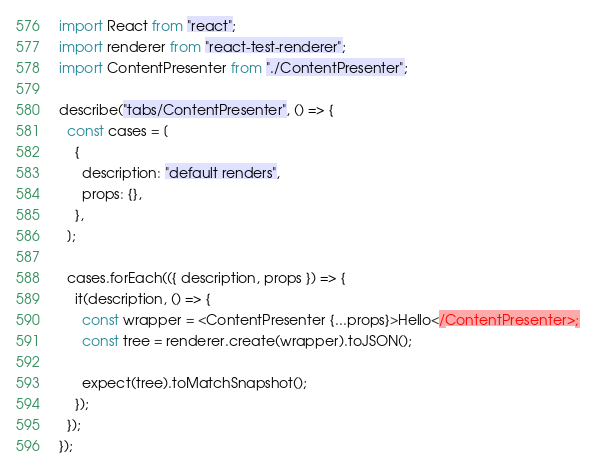<code> <loc_0><loc_0><loc_500><loc_500><_JavaScript_>import React from "react";
import renderer from "react-test-renderer";
import ContentPresenter from "./ContentPresenter";

describe("tabs/ContentPresenter", () => {
  const cases = [
    {
      description: "default renders",
      props: {},
    },
  ];

  cases.forEach(({ description, props }) => {
    it(description, () => {
      const wrapper = <ContentPresenter {...props}>Hello</ContentPresenter>;
      const tree = renderer.create(wrapper).toJSON();

      expect(tree).toMatchSnapshot();
    });
  });
});
</code> 